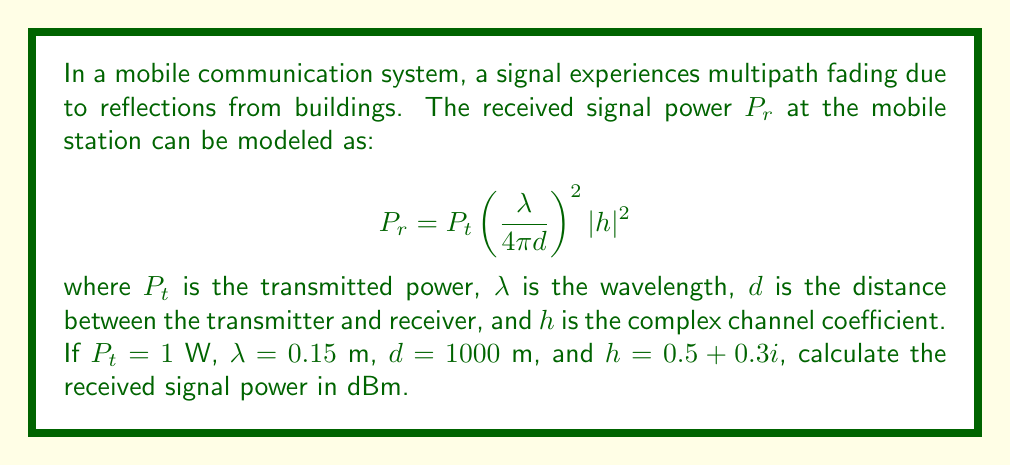Solve this math problem. To solve this problem, we'll follow these steps:

1) First, let's substitute the given values into the equation:

   $$P_r = 1 \cdot \left(\frac{0.15}{4\pi \cdot 1000}\right)^2 |h|^2$$

2) Calculate the magnitude squared of the complex channel coefficient $h$:
   
   $$|h|^2 = (0.5)^2 + (0.3)^2 = 0.25 + 0.09 = 0.34$$

3) Now, let's calculate $P_r$:

   $$P_r = \left(\frac{0.15}{4\pi \cdot 1000}\right)^2 \cdot 0.34$$
   
   $$= \left(\frac{0.15}{12566.37}\right)^2 \cdot 0.34$$
   
   $$= (1.4235 \times 10^{-8})^2 \cdot 0.34$$
   
   $$= 6.8898 \times 10^{-17} \text{ W}$$

4) To convert this to dBm, we use the formula:

   $$P_{dBm} = 10 \log_{10}\left(\frac{P_W}{1 \text{ mW}}\right)$$

   First, convert W to mW:
   
   $$6.8898 \times 10^{-17} \text{ W} = 6.8898 \times 10^{-14} \text{ mW}$$

   Then apply the formula:

   $$P_{dBm} = 10 \log_{10}(6.8898 \times 10^{-14})$$
   
   $$= 10 \cdot (-13.1618)$$
   
   $$= -131.618 \text{ dBm}$$

5) Rounding to two decimal places:

   $$P_{dBm} \approx -131.62 \text{ dBm}$$
Answer: $-131.62 \text{ dBm}$ 